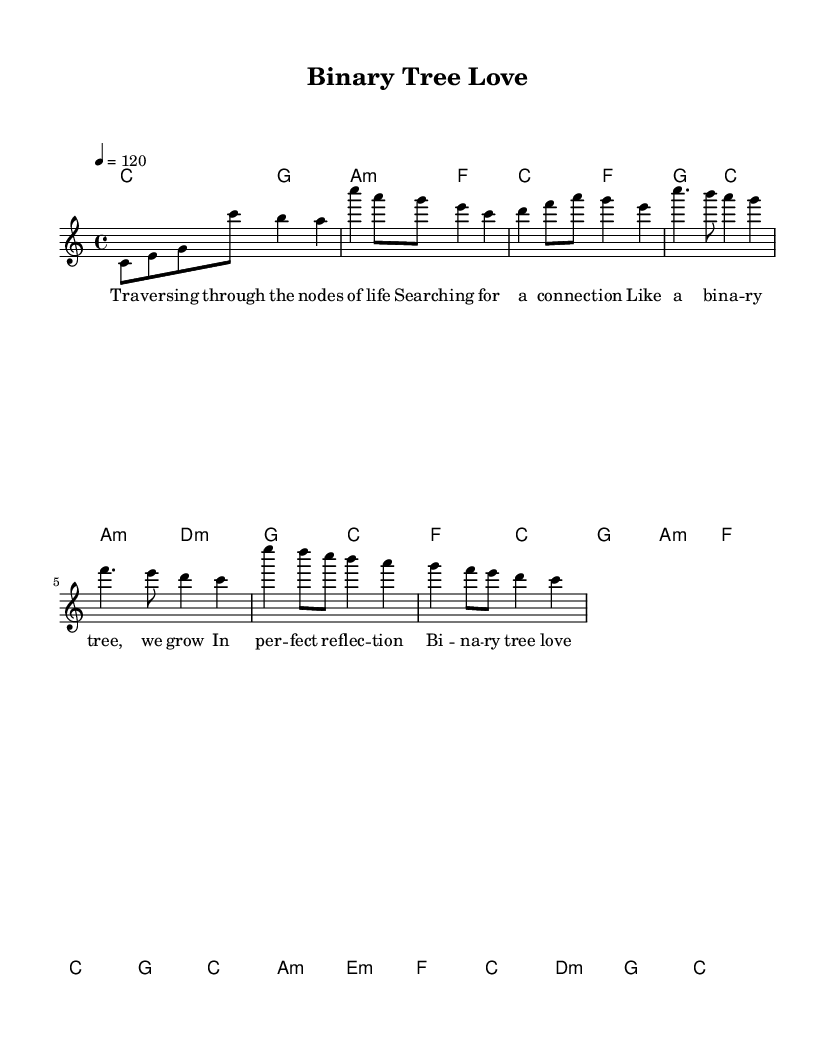What is the key signature of this music? The key signature is C major, which is indicated by the lack of sharps or flats in the music.
Answer: C major What is the time signature of this music? The time signature is displayed at the beginning of the score, showing that there are four beats in each measure.
Answer: 4/4 What is the tempo marking of this piece? The tempo marking indicates the speed at which the piece should be played, and it is set at a quarter note equaling 120 beats per minute.
Answer: 120 How many measures are in the chorus section? By counting the measures within the chorus, there are four distinct measures in total, as indicated in the music.
Answer: 4 What harmonic structure is used in the chorus? The harmonic structure for the chorus consists of the chords played, which are F, C, G, and A minor, suggesting a progression typical of pop music.
Answer: F, C, G, A minor What theme does the bridge introduce regarding emotions? The bridge introduces the concept of recursion in emotional experiences, suggesting depth and complexity, reflecting the lyrical content.
Answer: Recursion How does the song's title relate to its musical content? The title "Binary Tree Love" relates to the lyrics depicting a binary tree structure, reflecting themes of connection and balance within relationships, which is also mirrored in the song's harmonic choices.
Answer: Connection 